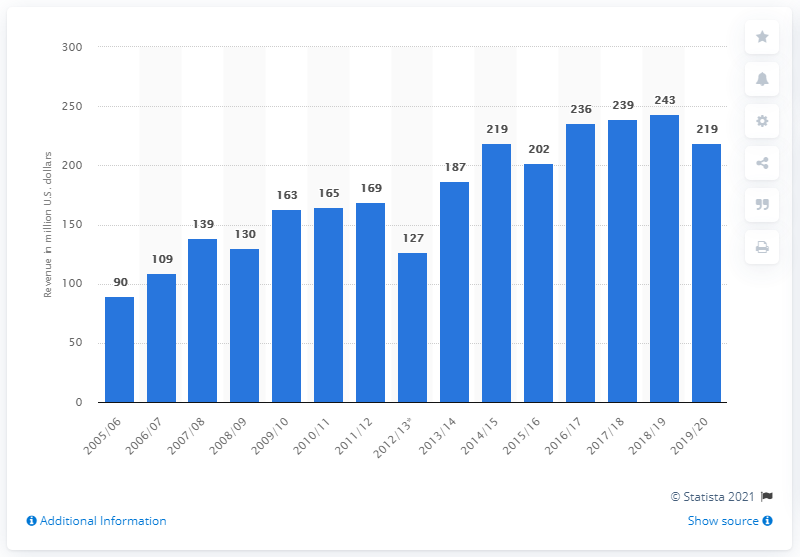Give some essential details in this illustration. The Montreal Canadiens last won a championship in the 2005/2006 season. The Montreal Canadiens earned 219 million U.S. dollars during the 2019/20 season. The revenue of the Montreal Canadiens in the 2019/2020 season was 219 million dollars. 